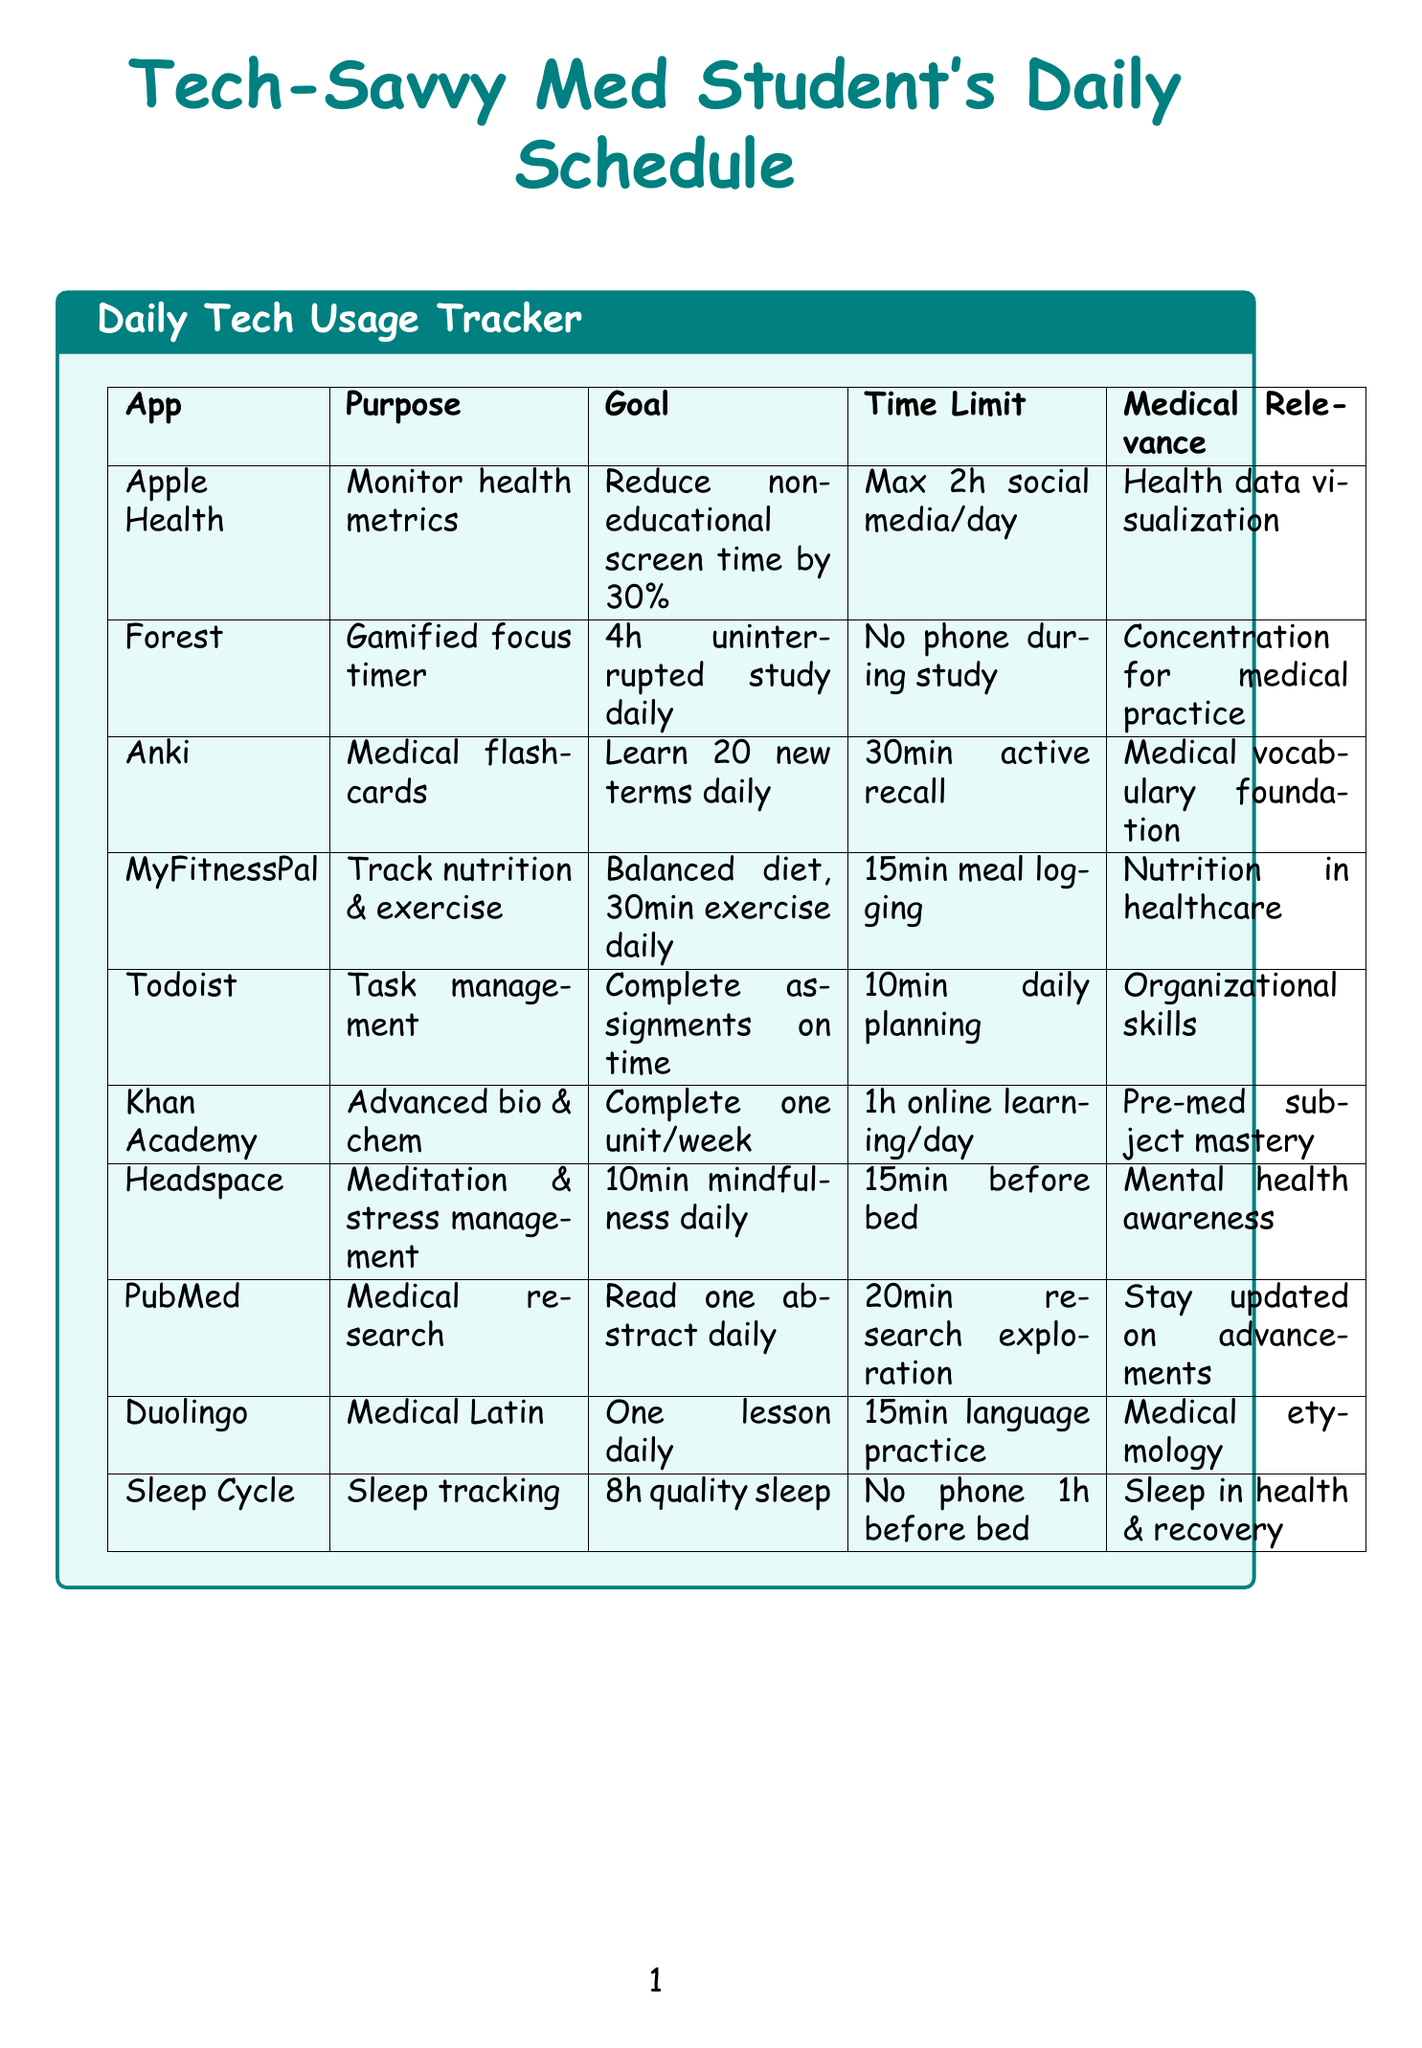What is the purpose of the Apple Health app? The purpose is to monitor overall health metrics and screen time.
Answer: Monitor overall health metrics and screen time How many hours of uninterrupted study does the Forest app aim for daily? The productivity goal for Forest is to complete 4 hours of uninterrupted study daily.
Answer: 4 hours What is the time limit for using Anki? The document states that the time limit for Anki is 30 minutes of active recall practice.
Answer: 30 minutes What is the medical relevance of using MyFitnessPal? The medical relevance is understanding the importance of nutrition in healthcare.
Answer: Understanding importance of nutrition in healthcare What is the goal for sleep according to Sleep Cycle? The productivity goal is to achieve 8 hours of quality sleep.
Answer: 8 hours Which app is used for guided meditation? The app used for guided meditation is Headspace.
Answer: Headspace What is the time limit for daily planning in Todoist? The time limit for Todoist is 10 minutes for daily planning.
Answer: 10 minutes How many medical terms does Anki help to learn daily? Anki helps to learn 20 new medical terms daily.
Answer: 20 What is the goal for Duolingo? The goal for Duolingo is to complete one lesson daily.
Answer: One lesson daily What should you prioritize for overall well-being, according to the tips? You should prioritize sleep and mindfulness for overall well-being.
Answer: Sleep and mindfulness 